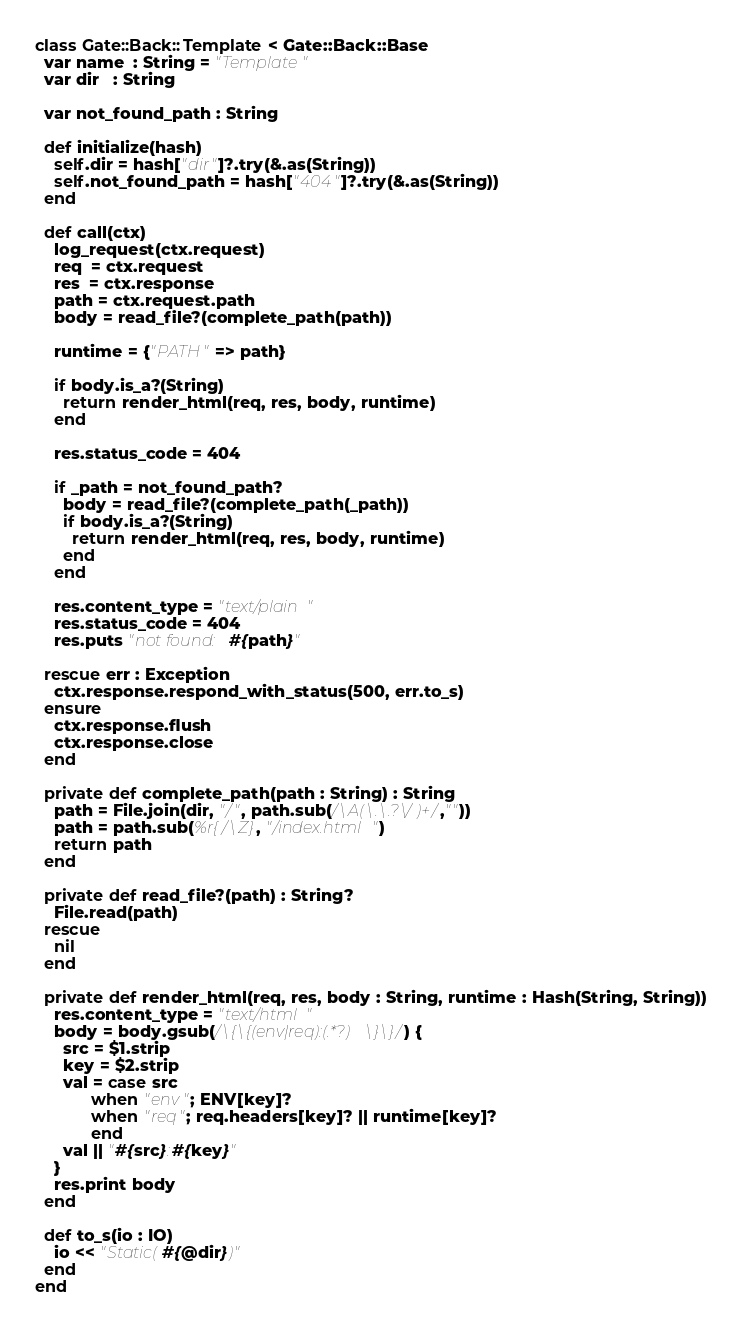Convert code to text. <code><loc_0><loc_0><loc_500><loc_500><_Crystal_>class Gate::Back::Template < Gate::Back::Base
  var name  : String = "Template"
  var dir   : String

  var not_found_path : String
  
  def initialize(hash)
    self.dir = hash["dir"]?.try(&.as(String))
    self.not_found_path = hash["404"]?.try(&.as(String))
  end

  def call(ctx)
    log_request(ctx.request)
    req  = ctx.request
    res  = ctx.response
    path = ctx.request.path    
    body = read_file?(complete_path(path))

    runtime = {"PATH" => path}
    
    if body.is_a?(String)
      return render_html(req, res, body, runtime)
    end

    res.status_code = 404

    if _path = not_found_path?
      body = read_file?(complete_path(_path))
      if body.is_a?(String)
        return render_html(req, res, body, runtime)
      end
    end

    res.content_type = "text/plain"
    res.status_code = 404
    res.puts "not found: #{path}"

  rescue err : Exception
    ctx.response.respond_with_status(500, err.to_s)
  ensure
    ctx.response.flush
    ctx.response.close
  end

  private def complete_path(path : String) : String
    path = File.join(dir, "/", path.sub(/\A(\.\.?\/)+/,""))
    path = path.sub(%r{/\Z}, "/index.html")
    return path
  end

  private def read_file?(path) : String?
    File.read(path)
  rescue
    nil
  end

  private def render_html(req, res, body : String, runtime : Hash(String, String))
    res.content_type = "text/html"
    body = body.gsub(/\{\{(env|req):(.*?)\}\}/) {
      src = $1.strip
      key = $2.strip
      val = case src
            when "env"; ENV[key]?
            when "req"; req.headers[key]? || runtime[key]?
            end
      val || "#{src}:#{key}"
    }
    res.print body
  end

  def to_s(io : IO)
    io << "Static(#{@dir})"
  end
end
</code> 